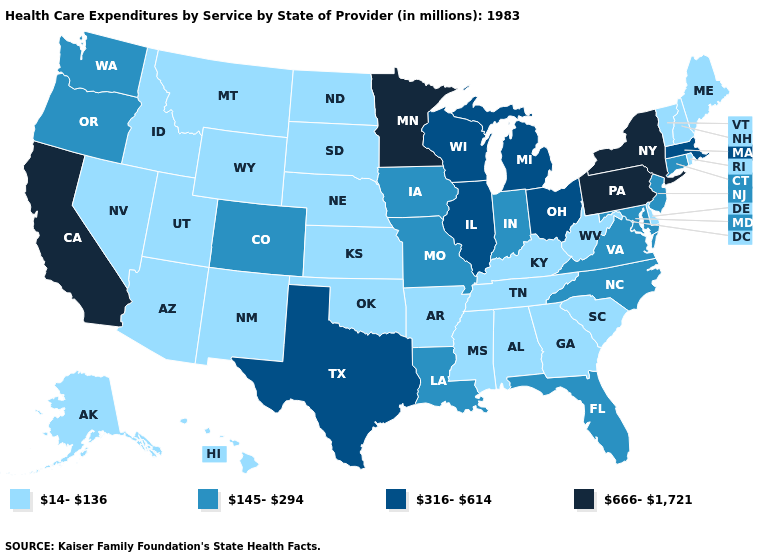Name the states that have a value in the range 145-294?
Keep it brief. Colorado, Connecticut, Florida, Indiana, Iowa, Louisiana, Maryland, Missouri, New Jersey, North Carolina, Oregon, Virginia, Washington. Name the states that have a value in the range 316-614?
Give a very brief answer. Illinois, Massachusetts, Michigan, Ohio, Texas, Wisconsin. Among the states that border New Mexico , which have the highest value?
Write a very short answer. Texas. Does Idaho have the highest value in the USA?
Keep it brief. No. Name the states that have a value in the range 14-136?
Short answer required. Alabama, Alaska, Arizona, Arkansas, Delaware, Georgia, Hawaii, Idaho, Kansas, Kentucky, Maine, Mississippi, Montana, Nebraska, Nevada, New Hampshire, New Mexico, North Dakota, Oklahoma, Rhode Island, South Carolina, South Dakota, Tennessee, Utah, Vermont, West Virginia, Wyoming. Name the states that have a value in the range 14-136?
Answer briefly. Alabama, Alaska, Arizona, Arkansas, Delaware, Georgia, Hawaii, Idaho, Kansas, Kentucky, Maine, Mississippi, Montana, Nebraska, Nevada, New Hampshire, New Mexico, North Dakota, Oklahoma, Rhode Island, South Carolina, South Dakota, Tennessee, Utah, Vermont, West Virginia, Wyoming. How many symbols are there in the legend?
Concise answer only. 4. Is the legend a continuous bar?
Keep it brief. No. What is the highest value in states that border Pennsylvania?
Answer briefly. 666-1,721. What is the highest value in states that border Washington?
Answer briefly. 145-294. Does Nebraska have the lowest value in the MidWest?
Be succinct. Yes. Name the states that have a value in the range 14-136?
Concise answer only. Alabama, Alaska, Arizona, Arkansas, Delaware, Georgia, Hawaii, Idaho, Kansas, Kentucky, Maine, Mississippi, Montana, Nebraska, Nevada, New Hampshire, New Mexico, North Dakota, Oklahoma, Rhode Island, South Carolina, South Dakota, Tennessee, Utah, Vermont, West Virginia, Wyoming. What is the highest value in the USA?
Give a very brief answer. 666-1,721. Does New Jersey have the highest value in the USA?
Keep it brief. No. How many symbols are there in the legend?
Give a very brief answer. 4. 